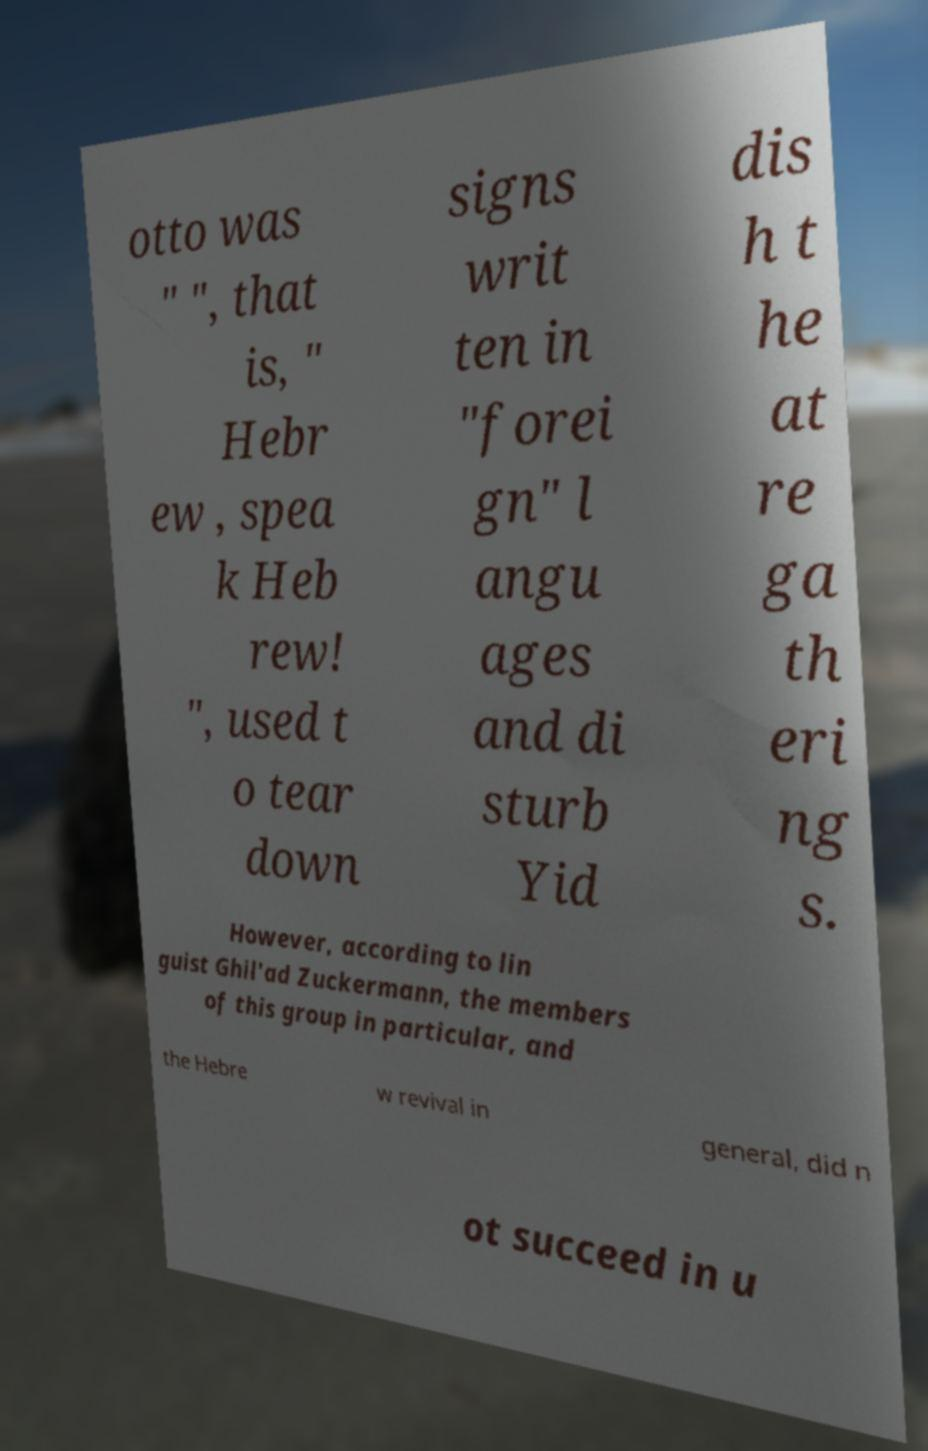I need the written content from this picture converted into text. Can you do that? otto was " ", that is, " Hebr ew , spea k Heb rew! ", used t o tear down signs writ ten in "forei gn" l angu ages and di sturb Yid dis h t he at re ga th eri ng s. However, according to lin guist Ghil'ad Zuckermann, the members of this group in particular, and the Hebre w revival in general, did n ot succeed in u 